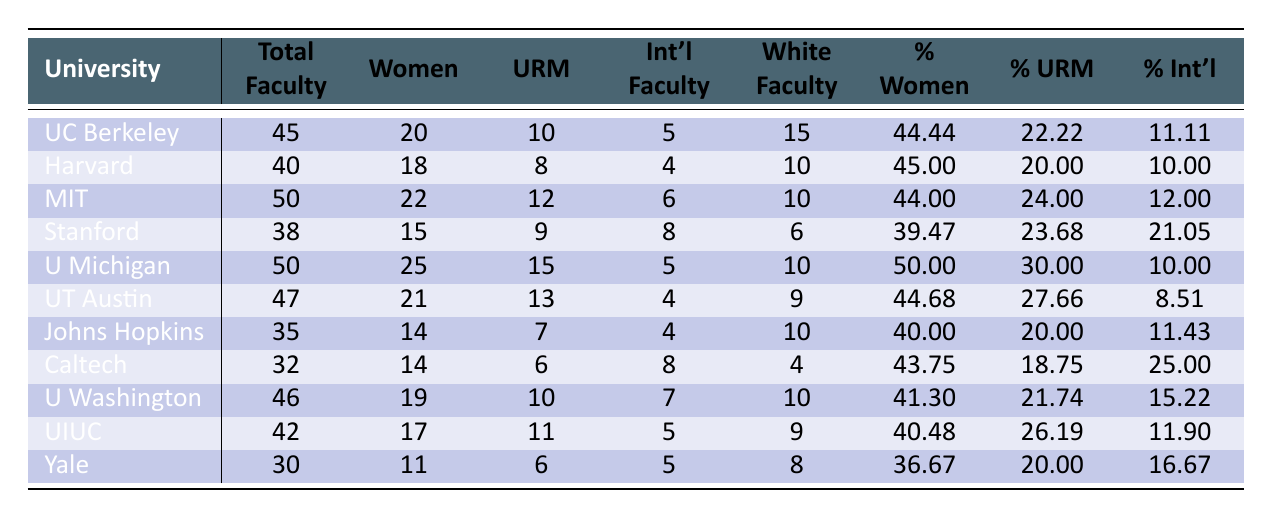What is the total number of faculty at Harvard University? The table shows that the total number of faculty at Harvard University is listed directly in the "Total Faculty" column. It indicates a total of 40.
Answer: 40 Which university has the highest percentage of women faculty? By comparing the "Percentage Women" column across all universities, the University of Michigan, Ann Arbor has the highest percentage at 50.00%.
Answer: University of Michigan, Ann Arbor How many faculty members at California Institute of Technology are international? The table shows the number of international faculty under the "International Faculty" column specifically for the California Institute of Technology, which indicates there are 8 international faculty members.
Answer: 8 What is the average percentage of underrepresented minorities across all listed universities? To calculate the average percentage of underrepresented minorities, sum the percentages from the "Percentage Underrepresented Minorities" column, then divide by the number of universities (11). The sum is (22.22 + 20.00 + 24.00 + 23.68 + 30.00 + 27.66 + 20.00 + 18.75 + 21.74 + 26.19 + 20.00) =  233.24, and dividing by 11 results in an average of approximately 21.20%.
Answer: 21.20% Is the percentage of international faculty greater than 20% in any university? By examining the "Percentage International Faculty" column, only the California Institute of Technology shows a value of 25.00%, which is greater than 20%.
Answer: Yes What is the difference in the number of underrepresented minorities between the University of Michigan and Yale University? Looking at the "Underrepresented Minorities" column, the University of Michigan has 15, while Yale University has 6. The difference is calculated as 15 - 6 = 9.
Answer: 9 Which university has the lowest percentage of women faculty? By checking the "Percentage Women" column, Yale University has the lowest percentage at 36.67%.
Answer: Yale University What percentage of faculty members at the University of Texas at Austin are underrepresented minorities? The table lists that the "Percentage Underrepresented Minorities" at the University of Texas at Austin is 27.66%.
Answer: 27.66% How many total underrepresented minority faculty are there across all universities combined? Adding the "Underrepresented Minorities" values from each university (10 + 8 + 12 + 9 + 15 + 13 + 7 + 6 + 10 + 11 + 6) gives a total of 87 underrepresented minority faculty across all universities.
Answer: 87 Which university has more women faculty: Massachusetts Institute of Technology or Stanford University? The "Women" column indicates that Massachusetts Institute of Technology has 22 women faculty while Stanford University has 15. Therefore, MIT has more women faculty.
Answer: Massachusetts Institute of Technology Is the total faculty number at Johns Hopkins University greater than the total number at Stanford University? Comparing the "Total Faculty" counts, Johns Hopkins has 35 and Stanford has 38, thus Johns Hopkins does not exceed Stanford.
Answer: No 